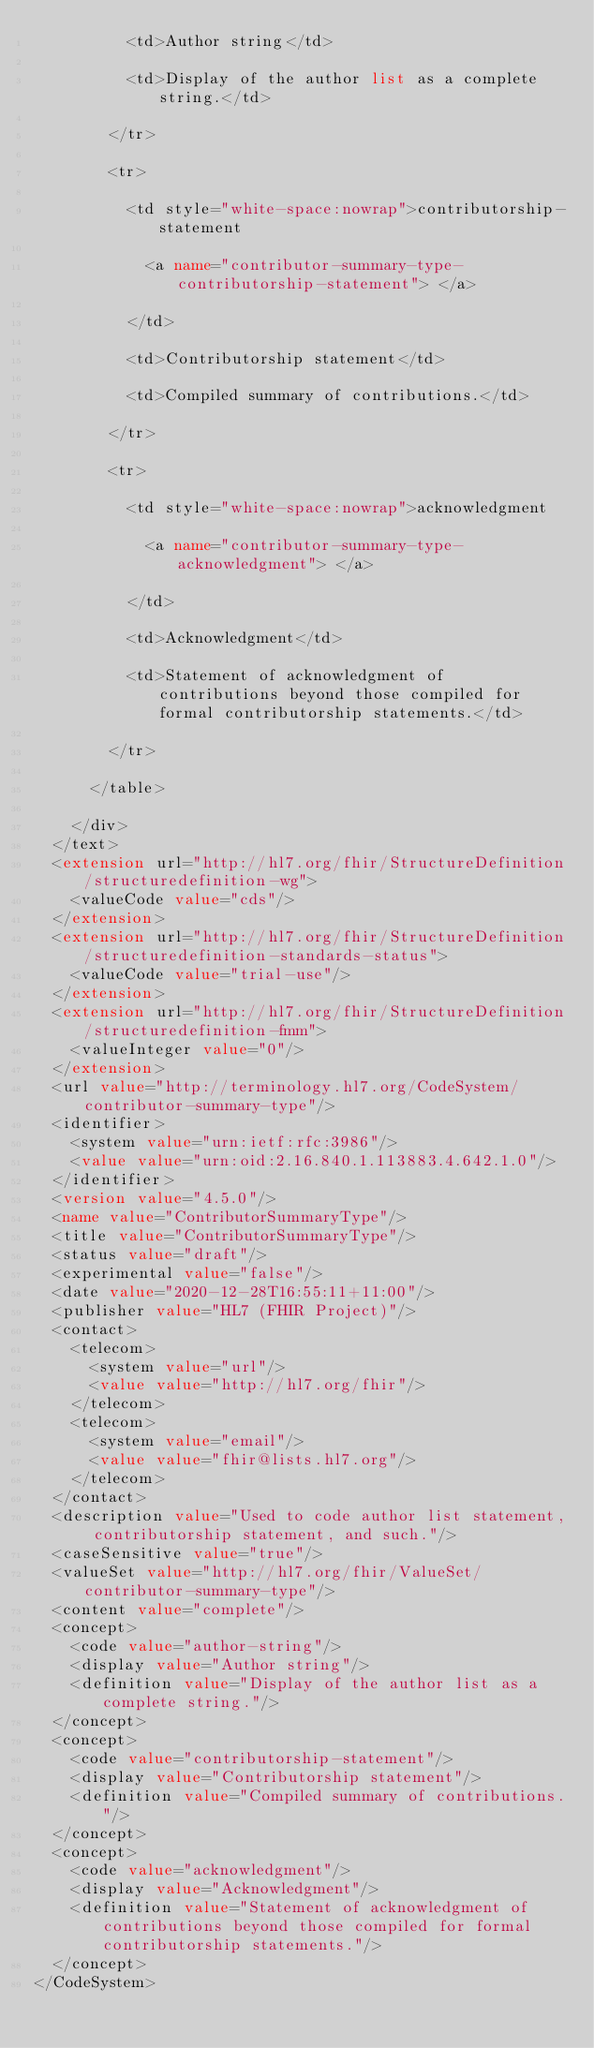Convert code to text. <code><loc_0><loc_0><loc_500><loc_500><_XML_>          <td>Author string</td>
          
          <td>Display of the author list as a complete string.</td>
        
        </tr>
        
        <tr>
          
          <td style="white-space:nowrap">contributorship-statement
            
            <a name="contributor-summary-type-contributorship-statement"> </a>
          
          </td>
          
          <td>Contributorship statement</td>
          
          <td>Compiled summary of contributions.</td>
        
        </tr>
        
        <tr>
          
          <td style="white-space:nowrap">acknowledgment
            
            <a name="contributor-summary-type-acknowledgment"> </a>
          
          </td>
          
          <td>Acknowledgment</td>
          
          <td>Statement of acknowledgment of contributions beyond those compiled for formal contributorship statements.</td>
        
        </tr>
      
      </table>
    
    </div>
  </text>
  <extension url="http://hl7.org/fhir/StructureDefinition/structuredefinition-wg">
    <valueCode value="cds"/>
  </extension>
  <extension url="http://hl7.org/fhir/StructureDefinition/structuredefinition-standards-status">
    <valueCode value="trial-use"/>
  </extension>
  <extension url="http://hl7.org/fhir/StructureDefinition/structuredefinition-fmm">
    <valueInteger value="0"/>
  </extension>
  <url value="http://terminology.hl7.org/CodeSystem/contributor-summary-type"/>
  <identifier>
    <system value="urn:ietf:rfc:3986"/>
    <value value="urn:oid:2.16.840.1.113883.4.642.1.0"/>
  </identifier>
  <version value="4.5.0"/>
  <name value="ContributorSummaryType"/>
  <title value="ContributorSummaryType"/>
  <status value="draft"/>
  <experimental value="false"/>
  <date value="2020-12-28T16:55:11+11:00"/>
  <publisher value="HL7 (FHIR Project)"/>
  <contact>
    <telecom>
      <system value="url"/>
      <value value="http://hl7.org/fhir"/>
    </telecom>
    <telecom>
      <system value="email"/>
      <value value="fhir@lists.hl7.org"/>
    </telecom>
  </contact>
  <description value="Used to code author list statement, contributorship statement, and such."/>
  <caseSensitive value="true"/>
  <valueSet value="http://hl7.org/fhir/ValueSet/contributor-summary-type"/>
  <content value="complete"/>
  <concept>
    <code value="author-string"/>
    <display value="Author string"/>
    <definition value="Display of the author list as a complete string."/>
  </concept>
  <concept>
    <code value="contributorship-statement"/>
    <display value="Contributorship statement"/>
    <definition value="Compiled summary of contributions."/>
  </concept>
  <concept>
    <code value="acknowledgment"/>
    <display value="Acknowledgment"/>
    <definition value="Statement of acknowledgment of contributions beyond those compiled for formal contributorship statements."/>
  </concept>
</CodeSystem></code> 